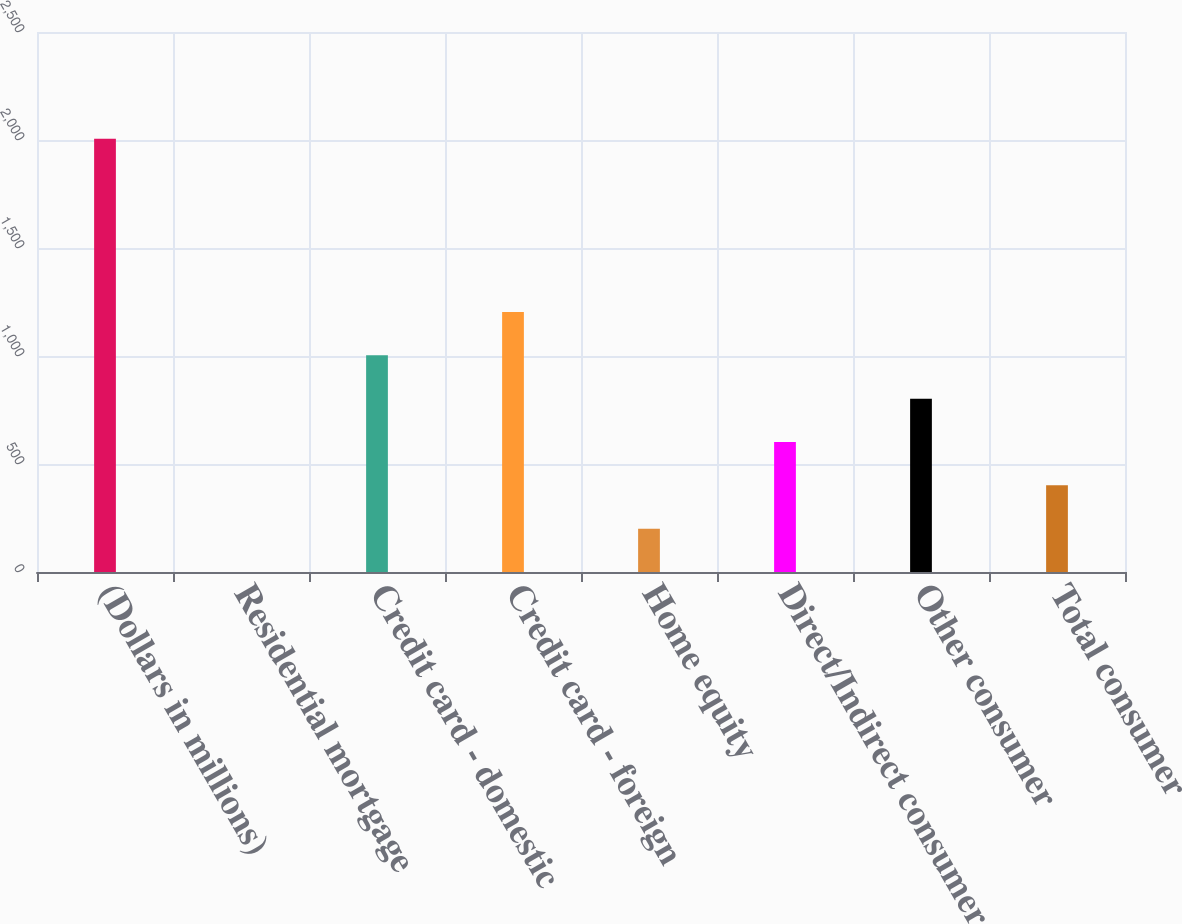Convert chart to OTSL. <chart><loc_0><loc_0><loc_500><loc_500><bar_chart><fcel>(Dollars in millions)<fcel>Residential mortgage<fcel>Credit card - domestic<fcel>Credit card - foreign<fcel>Home equity<fcel>Direct/Indirect consumer<fcel>Other consumer<fcel>Total consumer<nl><fcel>2006<fcel>0.02<fcel>1003.02<fcel>1203.62<fcel>200.62<fcel>601.82<fcel>802.42<fcel>401.22<nl></chart> 